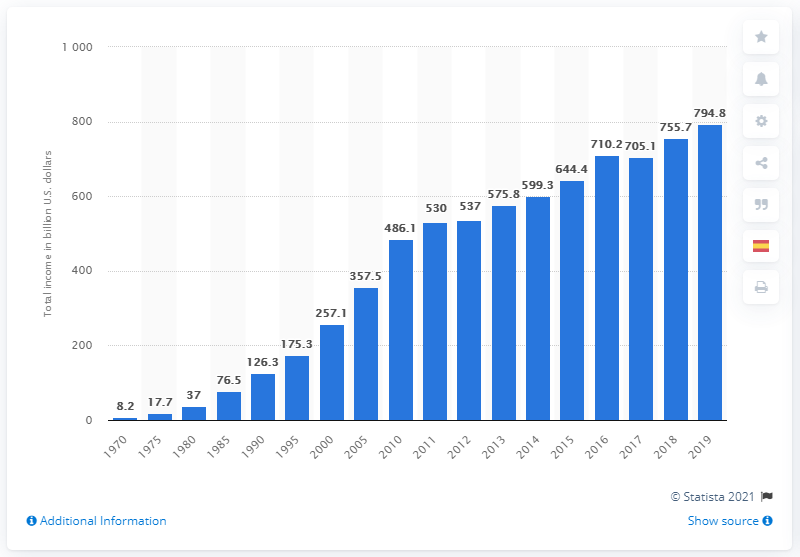Identify some key points in this picture. In 1970, the total income of the Medicare program was $8.2 billion. The Medicare program's total income, 794.8, was 50 years later. 